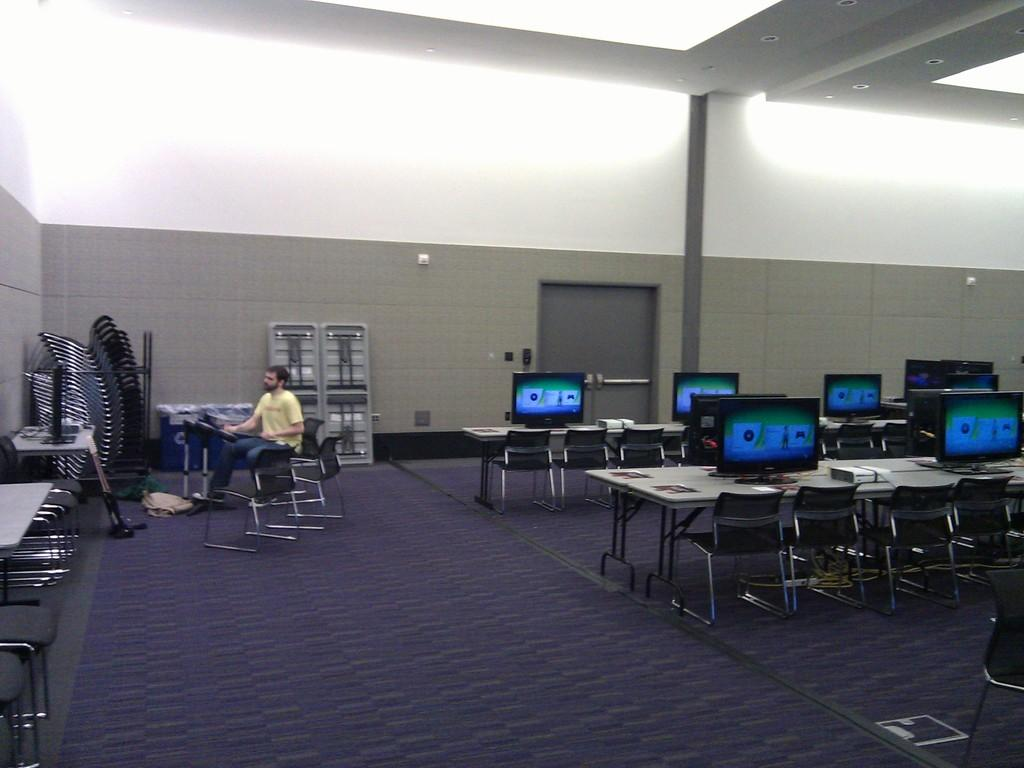What type of furniture is present in the image? There is a table and a chair in the image. What is the man in the image doing? The man is sitting on the chair. What can be seen on or near the table in the image? There is a system (possibly a computer or electronic device) in the image. What type of apparel is the man wearing in the image? The provided facts do not mention the man's clothing, so we cannot determine the type of apparel he is wearing. --- Facts: 1. There is a car in the image. 2. The car is parked on the street. 3. There are trees in the background of the image. 4. The sky is visible in the image. Absurd Topics: animals, ocean, music Conversation: What is the main subject of the image? The main subject of the image is a car. Where is the car located in the image? The car is parked on the street. What can be seen in the background of the image? There are trees in the background of the image. What is visible at the top of the image? The sky is visible in the image. Reasoning: Let's think step by step in order to produce the conversation. We start by identifying the main subject of the image, which is the car. Then, we describe the car's location, which is parked on the street. Next, we mention the presence of trees in the background and the sky visible at the top of the image. Absurd Question/Answer: What type of animals can be seen in the ocean can be seen in the image? There are no animals or ocean visible in the image; it features a car parked on the street with trees and sky in the background. 